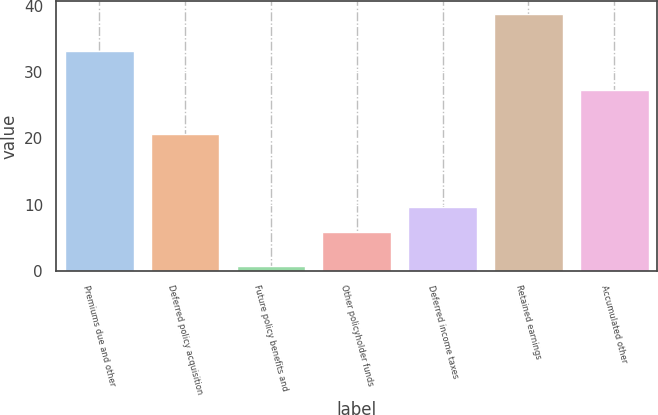Convert chart. <chart><loc_0><loc_0><loc_500><loc_500><bar_chart><fcel>Premiums due and other<fcel>Deferred policy acquisition<fcel>Future policy benefits and<fcel>Other policyholder funds<fcel>Deferred income taxes<fcel>Retained earnings<fcel>Accumulated other<nl><fcel>33.2<fcel>20.6<fcel>0.8<fcel>5.8<fcel>9.59<fcel>38.7<fcel>27.2<nl></chart> 